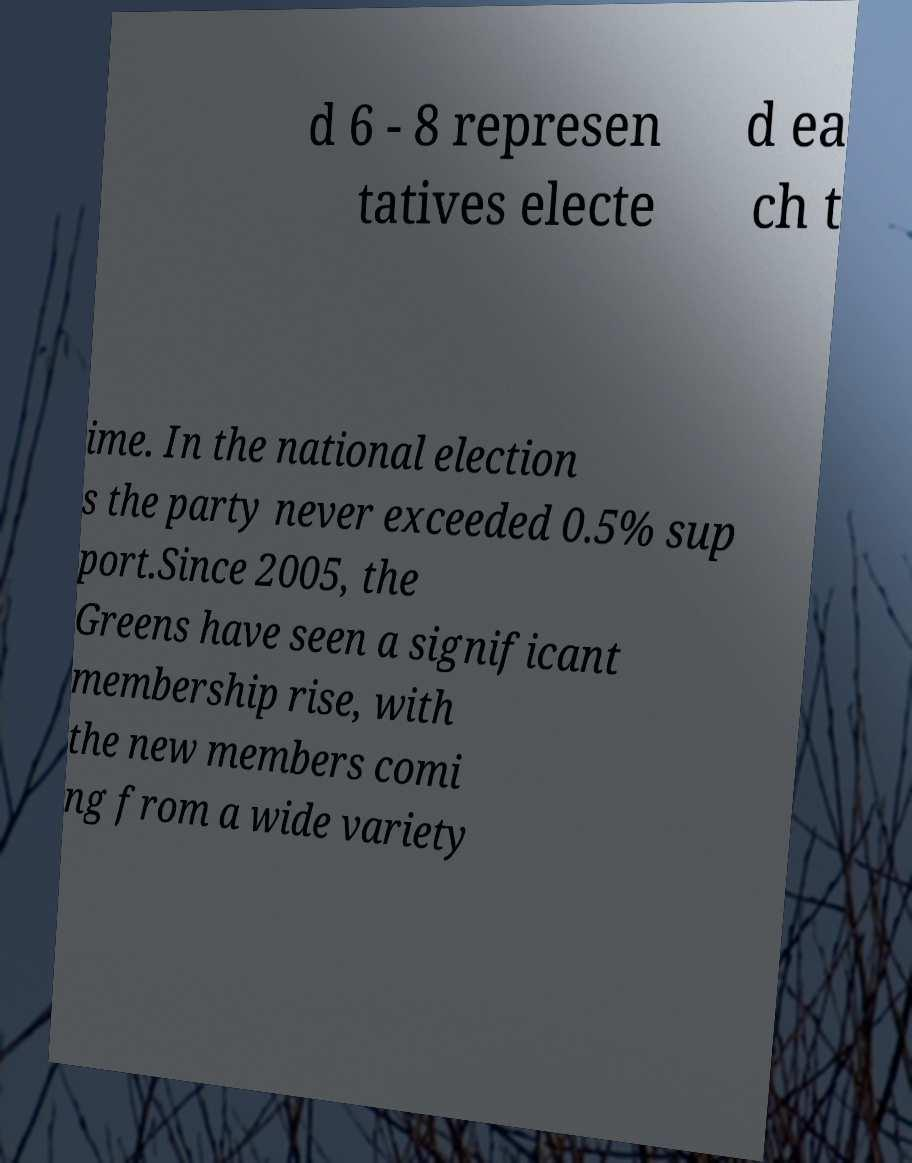I need the written content from this picture converted into text. Can you do that? d 6 - 8 represen tatives electe d ea ch t ime. In the national election s the party never exceeded 0.5% sup port.Since 2005, the Greens have seen a significant membership rise, with the new members comi ng from a wide variety 